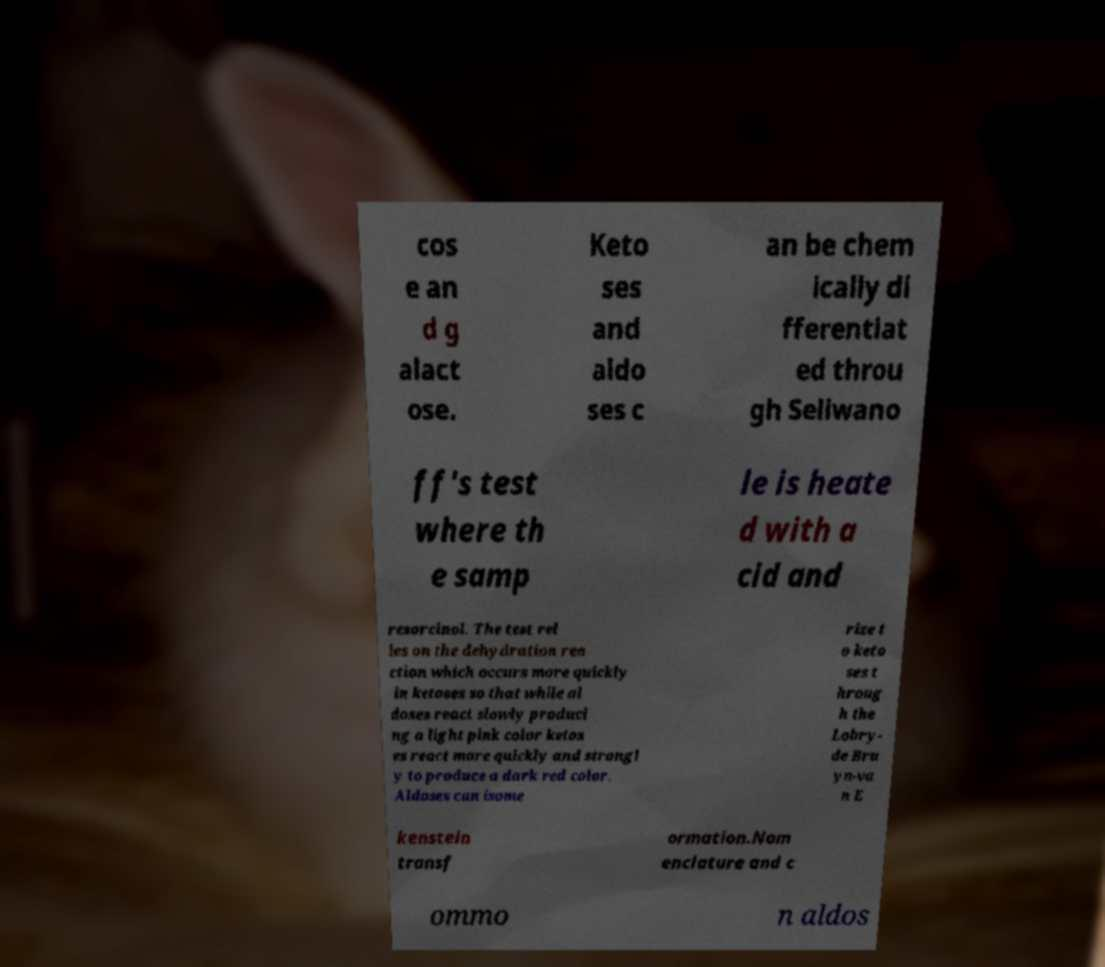Can you accurately transcribe the text from the provided image for me? cos e an d g alact ose. Keto ses and aldo ses c an be chem ically di fferentiat ed throu gh Seliwano ff's test where th e samp le is heate d with a cid and resorcinol. The test rel ies on the dehydration rea ction which occurs more quickly in ketoses so that while al doses react slowly produci ng a light pink color ketos es react more quickly and strongl y to produce a dark red color. Aldoses can isome rize t o keto ses t hroug h the Lobry- de Bru yn-va n E kenstein transf ormation.Nom enclature and c ommo n aldos 